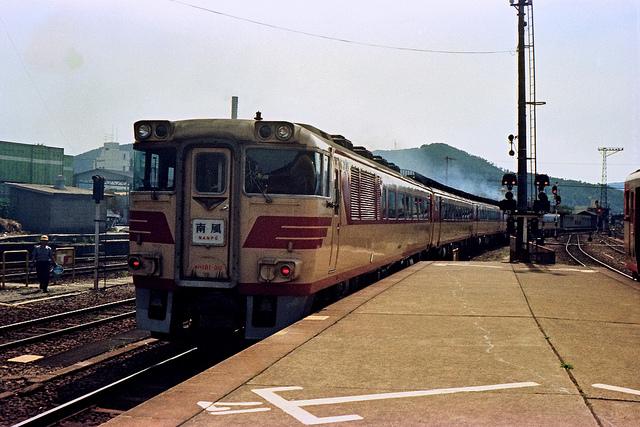What color is the smoke coming from the train?
Be succinct. White. Is this train pulling into a station?
Give a very brief answer. Yes. Is there a railway worker on the tracks?
Concise answer only. Yes. What is the number on the train?
Short answer required. 81-39. What color is the painting on the ground?
Write a very short answer. White. 